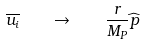Convert formula to latex. <formula><loc_0><loc_0><loc_500><loc_500>\overline { u _ { i } } \quad \rightarrow \quad \frac { r } { M _ { P } } \widehat { p }</formula> 